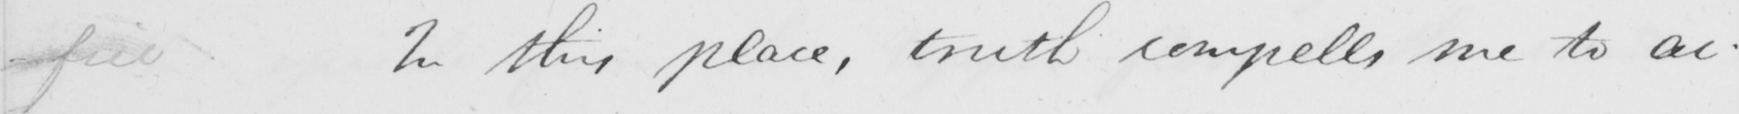Transcribe the text shown in this historical manuscript line. In this place , truth compells me to ac- 